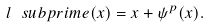<formula> <loc_0><loc_0><loc_500><loc_500>l \ s u b p r i m e ( x ) = x + \psi ^ { p } ( x ) .</formula> 